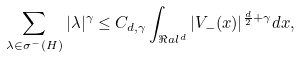<formula> <loc_0><loc_0><loc_500><loc_500>\sum _ { \lambda \in \sigma ^ { - } ( H ) } | \lambda | ^ { \gamma } \leq C _ { d , \gamma } \int _ { \Re a l ^ { d } } | V _ { - } ( x ) | ^ { \frac { d } { 2 } + \gamma } d x ,</formula> 